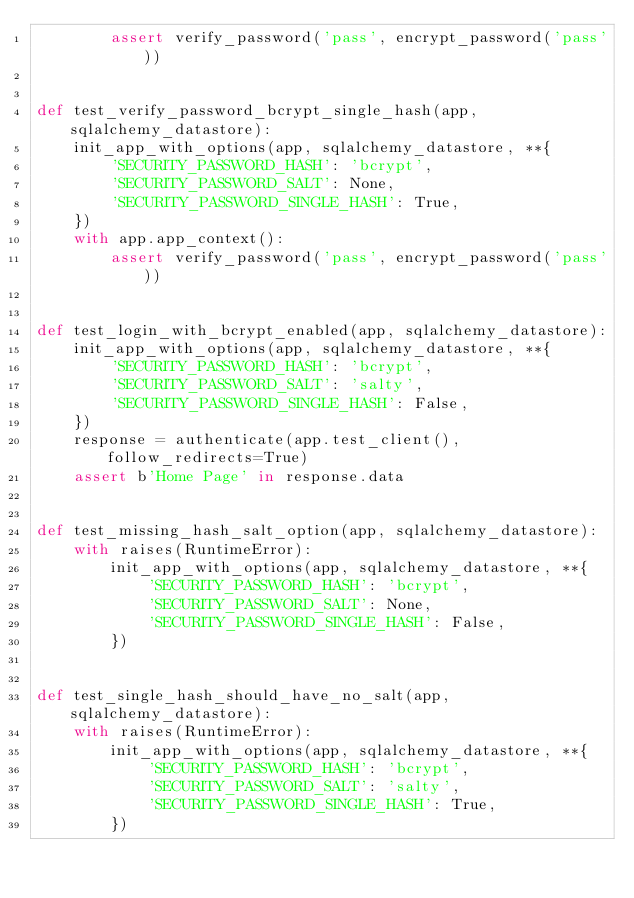Convert code to text. <code><loc_0><loc_0><loc_500><loc_500><_Python_>        assert verify_password('pass', encrypt_password('pass'))


def test_verify_password_bcrypt_single_hash(app, sqlalchemy_datastore):
    init_app_with_options(app, sqlalchemy_datastore, **{
        'SECURITY_PASSWORD_HASH': 'bcrypt',
        'SECURITY_PASSWORD_SALT': None,
        'SECURITY_PASSWORD_SINGLE_HASH': True,
    })
    with app.app_context():
        assert verify_password('pass', encrypt_password('pass'))


def test_login_with_bcrypt_enabled(app, sqlalchemy_datastore):
    init_app_with_options(app, sqlalchemy_datastore, **{
        'SECURITY_PASSWORD_HASH': 'bcrypt',
        'SECURITY_PASSWORD_SALT': 'salty',
        'SECURITY_PASSWORD_SINGLE_HASH': False,
    })
    response = authenticate(app.test_client(), follow_redirects=True)
    assert b'Home Page' in response.data


def test_missing_hash_salt_option(app, sqlalchemy_datastore):
    with raises(RuntimeError):
        init_app_with_options(app, sqlalchemy_datastore, **{
            'SECURITY_PASSWORD_HASH': 'bcrypt',
            'SECURITY_PASSWORD_SALT': None,
            'SECURITY_PASSWORD_SINGLE_HASH': False,
        })


def test_single_hash_should_have_no_salt(app, sqlalchemy_datastore):
    with raises(RuntimeError):
        init_app_with_options(app, sqlalchemy_datastore, **{
            'SECURITY_PASSWORD_HASH': 'bcrypt',
            'SECURITY_PASSWORD_SALT': 'salty',
            'SECURITY_PASSWORD_SINGLE_HASH': True,
        })
</code> 